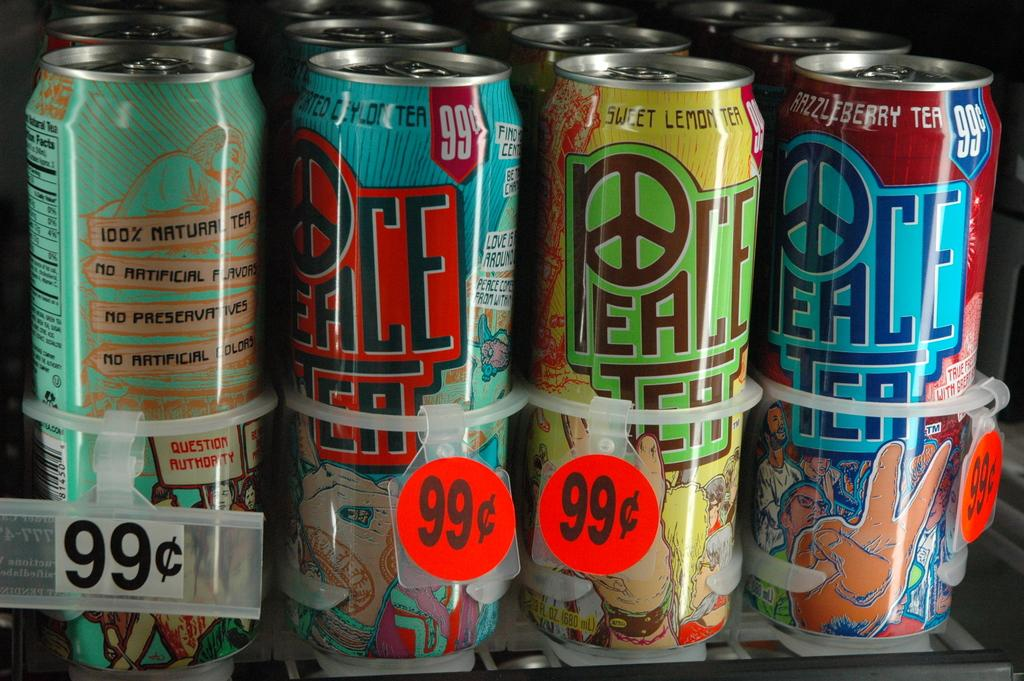<image>
Create a compact narrative representing the image presented. Cans of Peace Tea are selling for 99 cents. 